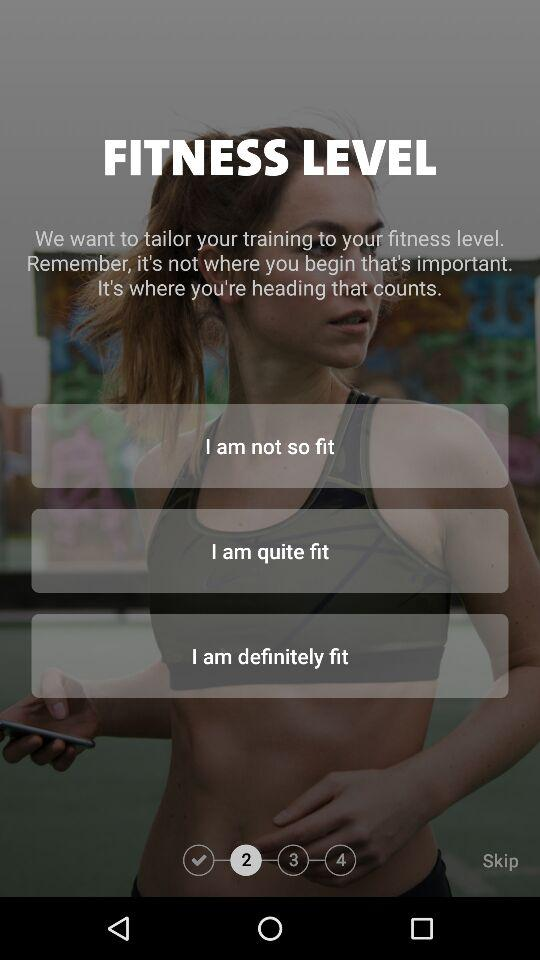How many steps are there in the fitness level question?
Answer the question using a single word or phrase. 4 